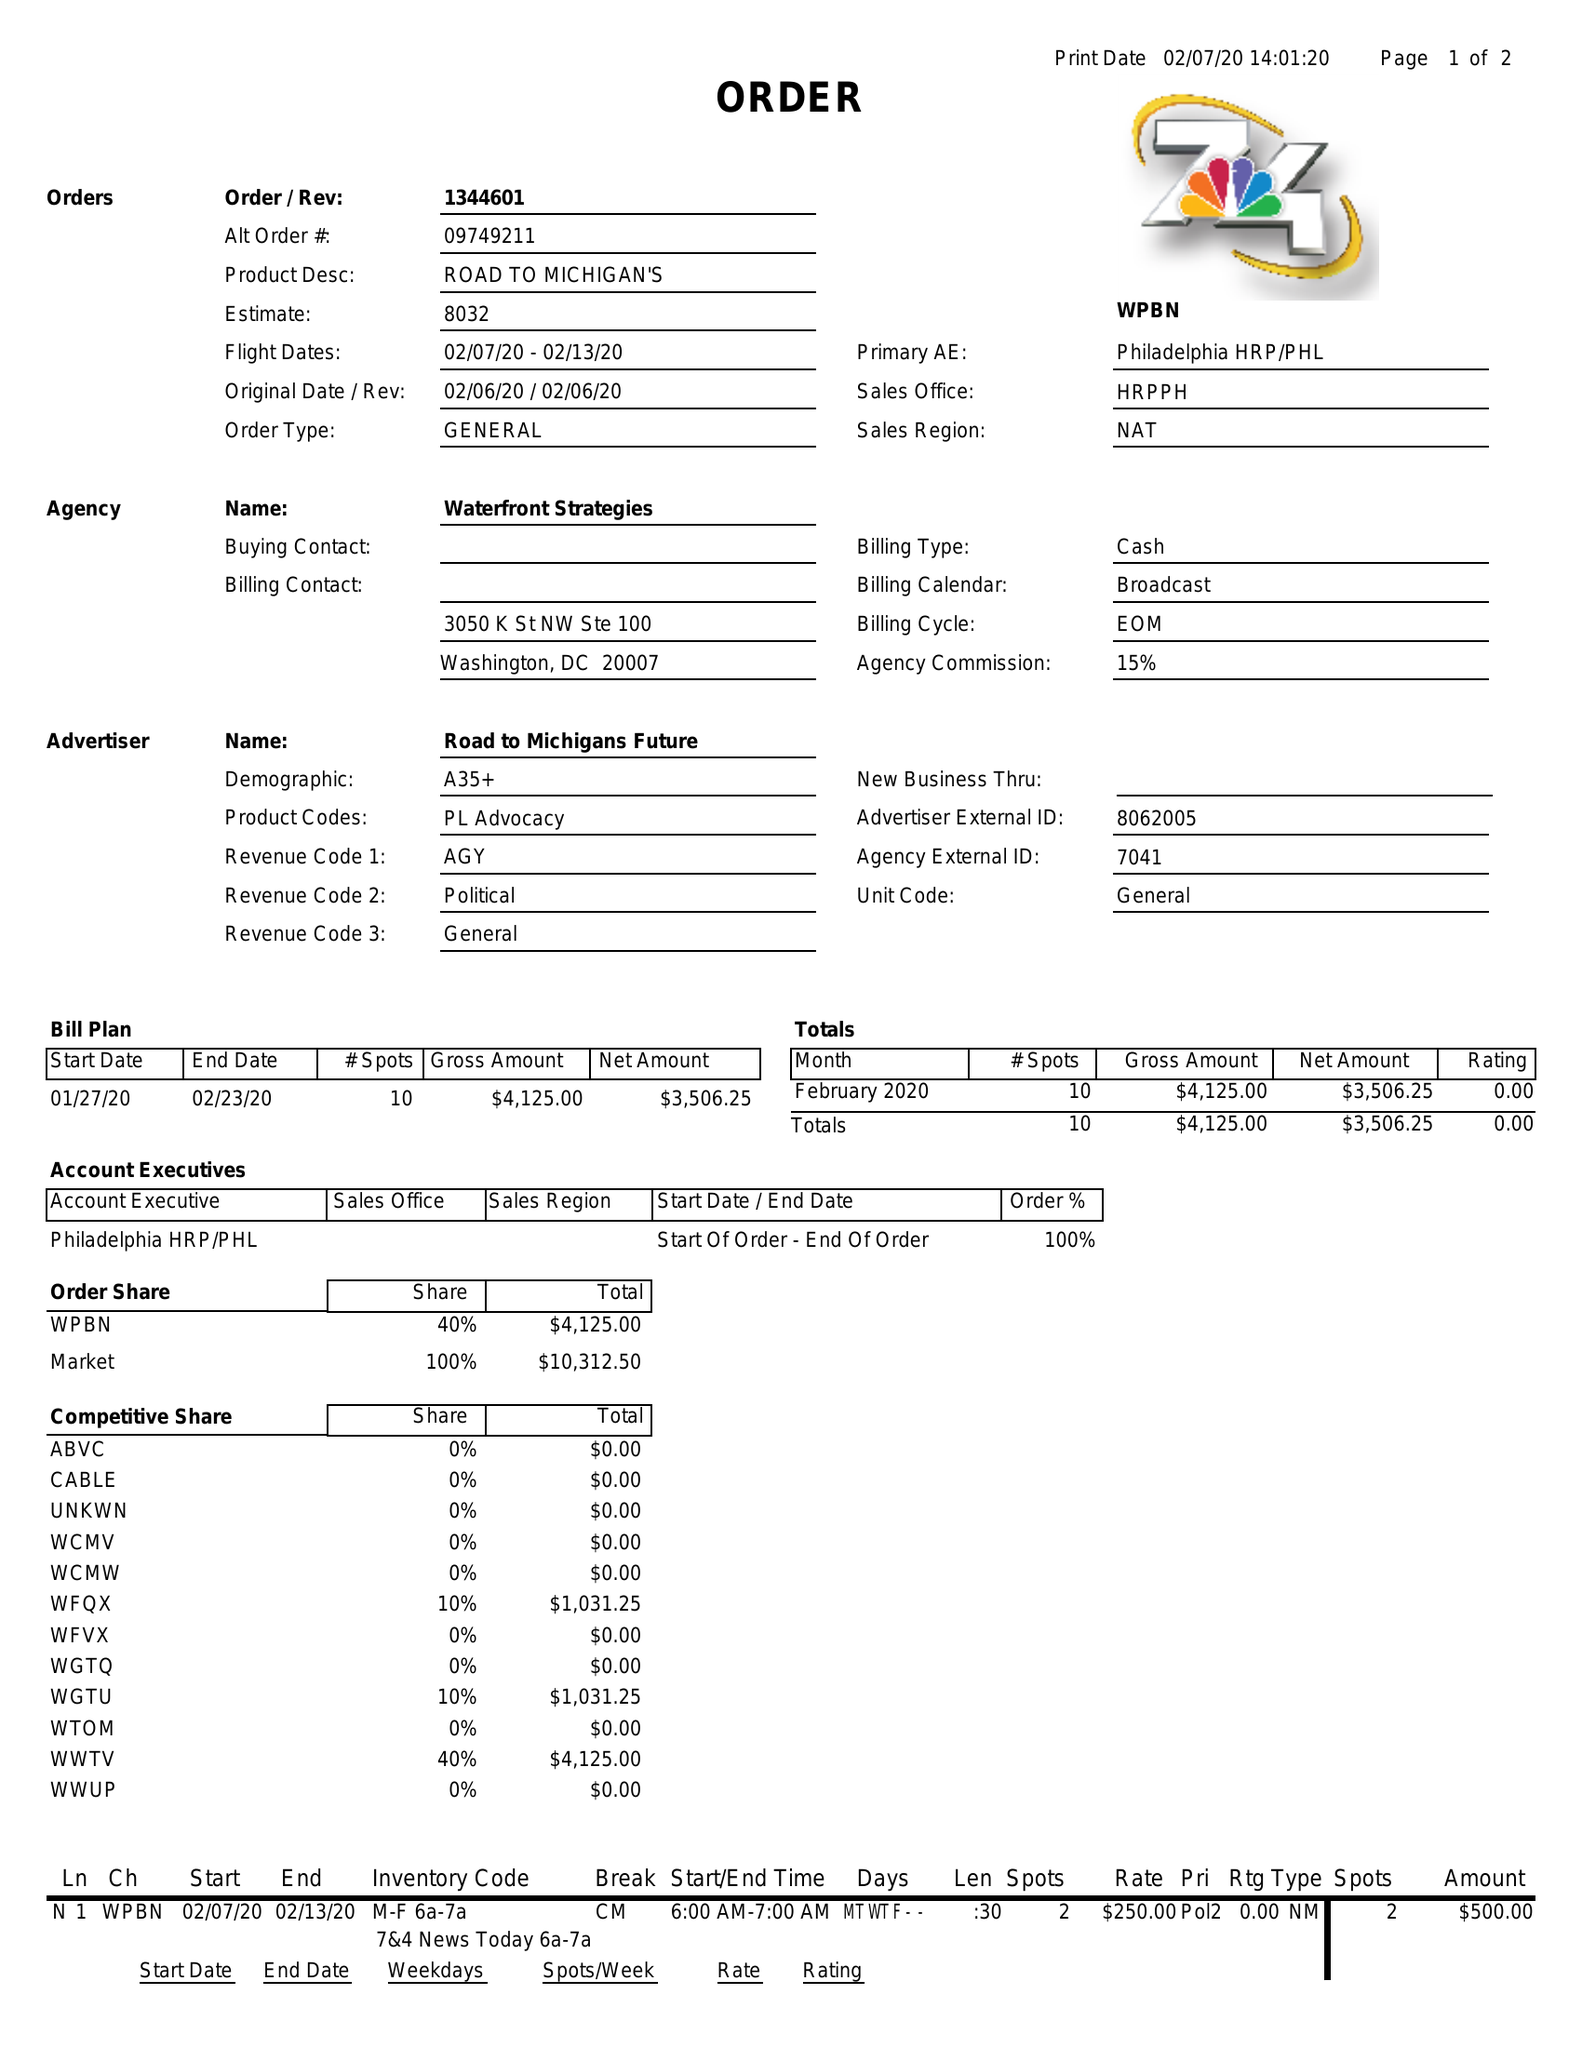What is the value for the advertiser?
Answer the question using a single word or phrase. ROAD TO MICHIGANS FUTURE 